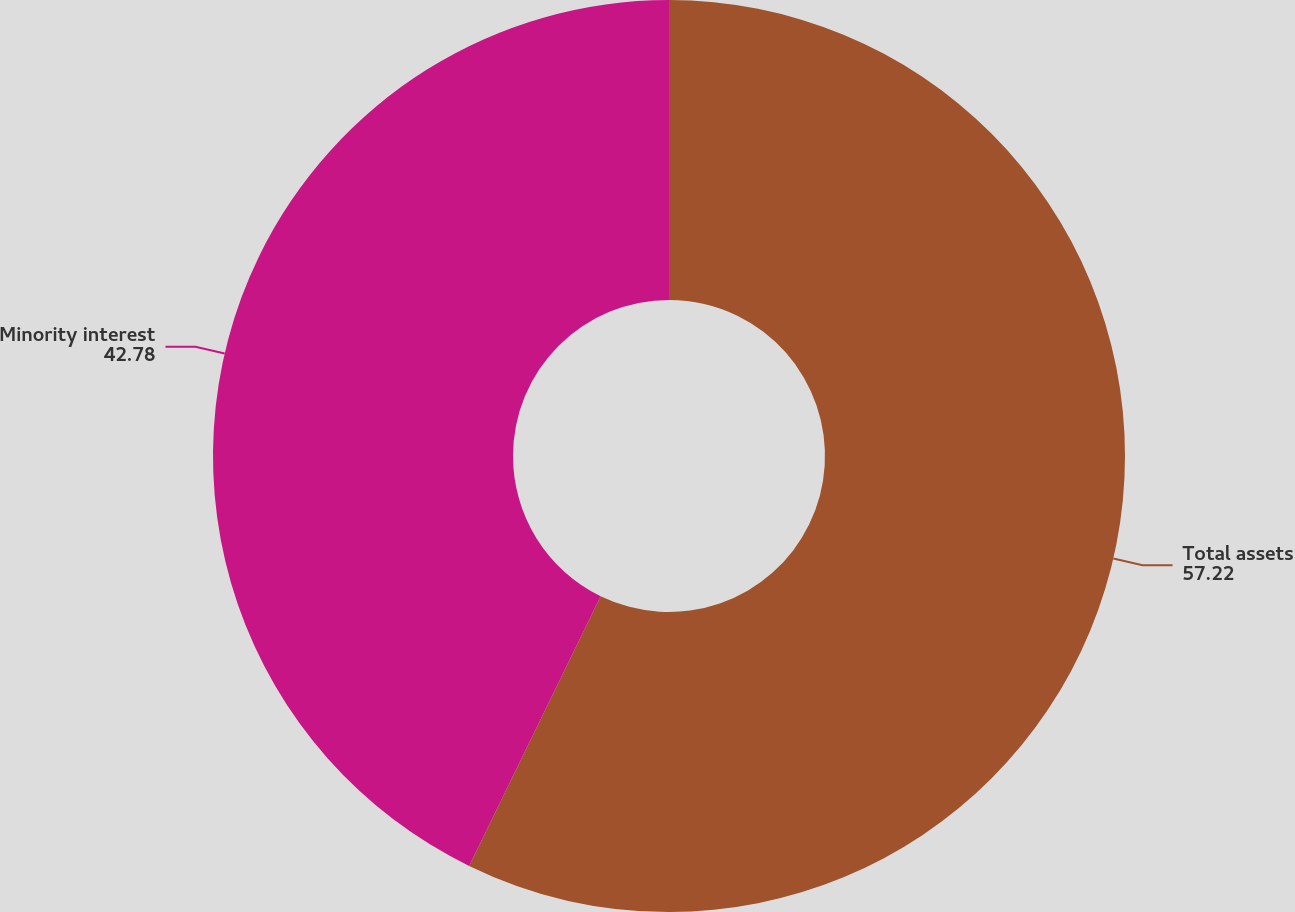Convert chart. <chart><loc_0><loc_0><loc_500><loc_500><pie_chart><fcel>Total assets<fcel>Minority interest<nl><fcel>57.22%<fcel>42.78%<nl></chart> 